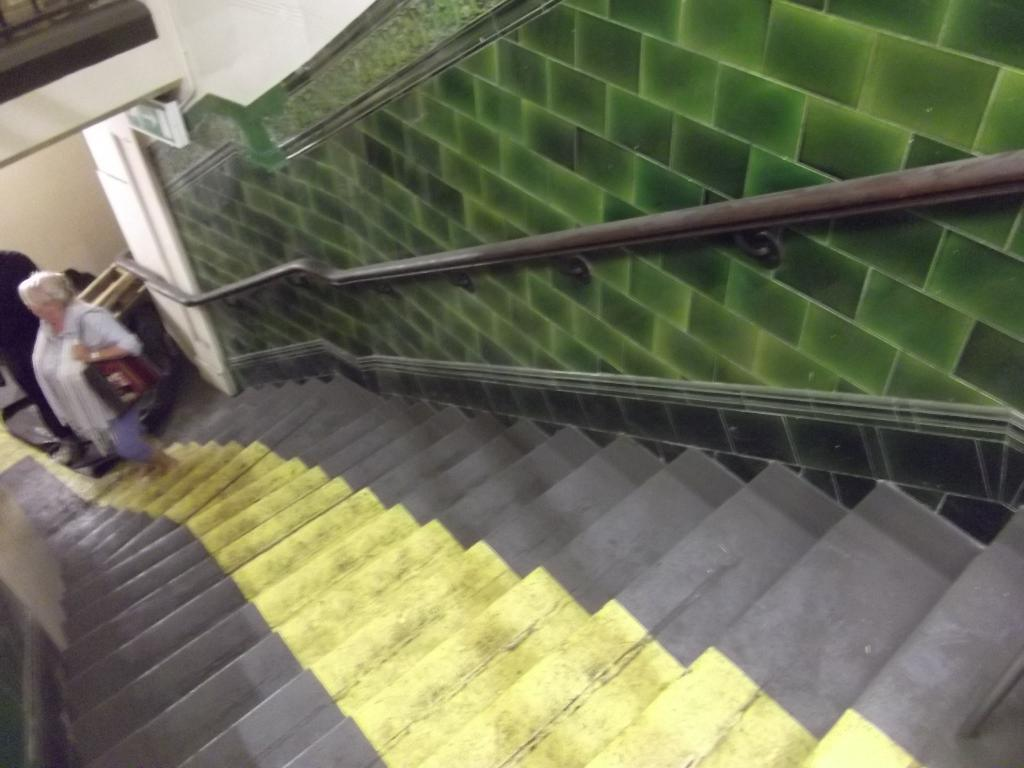Who is present in the image? There are people in the image. What are the people doing in the image? The people are on stairs. Can you describe the clothing of one of the people? One person is wearing a bag. What can be seen in the background of the image? There are rods and a wall visible in the background. What type of club is being used by the person on the stairs? There is no club present in the image; the people are simply standing on the stairs. Can you describe the ground on which the stairs are built? The ground is not visible in the image, as it only shows the people on the stairs and the background. 